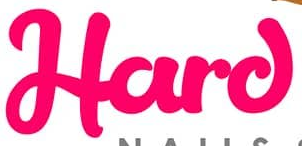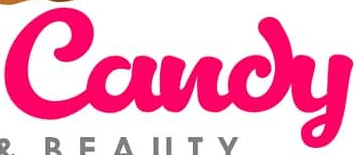What words are shown in these images in order, separated by a semicolon? Hard; Candy 